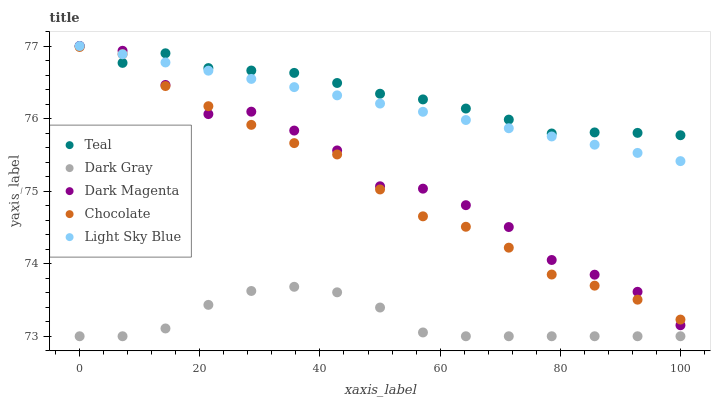Does Dark Gray have the minimum area under the curve?
Answer yes or no. Yes. Does Teal have the maximum area under the curve?
Answer yes or no. Yes. Does Light Sky Blue have the minimum area under the curve?
Answer yes or no. No. Does Light Sky Blue have the maximum area under the curve?
Answer yes or no. No. Is Light Sky Blue the smoothest?
Answer yes or no. Yes. Is Dark Magenta the roughest?
Answer yes or no. Yes. Is Dark Magenta the smoothest?
Answer yes or no. No. Is Light Sky Blue the roughest?
Answer yes or no. No. Does Dark Gray have the lowest value?
Answer yes or no. Yes. Does Light Sky Blue have the lowest value?
Answer yes or no. No. Does Teal have the highest value?
Answer yes or no. Yes. Does Chocolate have the highest value?
Answer yes or no. No. Is Dark Gray less than Chocolate?
Answer yes or no. Yes. Is Light Sky Blue greater than Dark Gray?
Answer yes or no. Yes. Does Dark Magenta intersect Teal?
Answer yes or no. Yes. Is Dark Magenta less than Teal?
Answer yes or no. No. Is Dark Magenta greater than Teal?
Answer yes or no. No. Does Dark Gray intersect Chocolate?
Answer yes or no. No. 